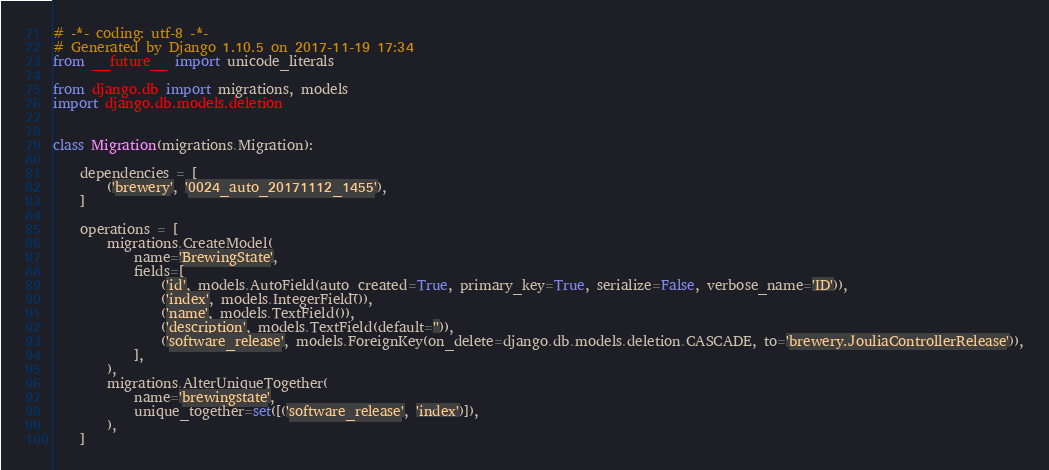<code> <loc_0><loc_0><loc_500><loc_500><_Python_># -*- coding: utf-8 -*-
# Generated by Django 1.10.5 on 2017-11-19 17:34
from __future__ import unicode_literals

from django.db import migrations, models
import django.db.models.deletion


class Migration(migrations.Migration):

    dependencies = [
        ('brewery', '0024_auto_20171112_1455'),
    ]

    operations = [
        migrations.CreateModel(
            name='BrewingState',
            fields=[
                ('id', models.AutoField(auto_created=True, primary_key=True, serialize=False, verbose_name='ID')),
                ('index', models.IntegerField()),
                ('name', models.TextField()),
                ('description', models.TextField(default='')),
                ('software_release', models.ForeignKey(on_delete=django.db.models.deletion.CASCADE, to='brewery.JouliaControllerRelease')),
            ],
        ),
        migrations.AlterUniqueTogether(
            name='brewingstate',
            unique_together=set([('software_release', 'index')]),
        ),
    ]
</code> 